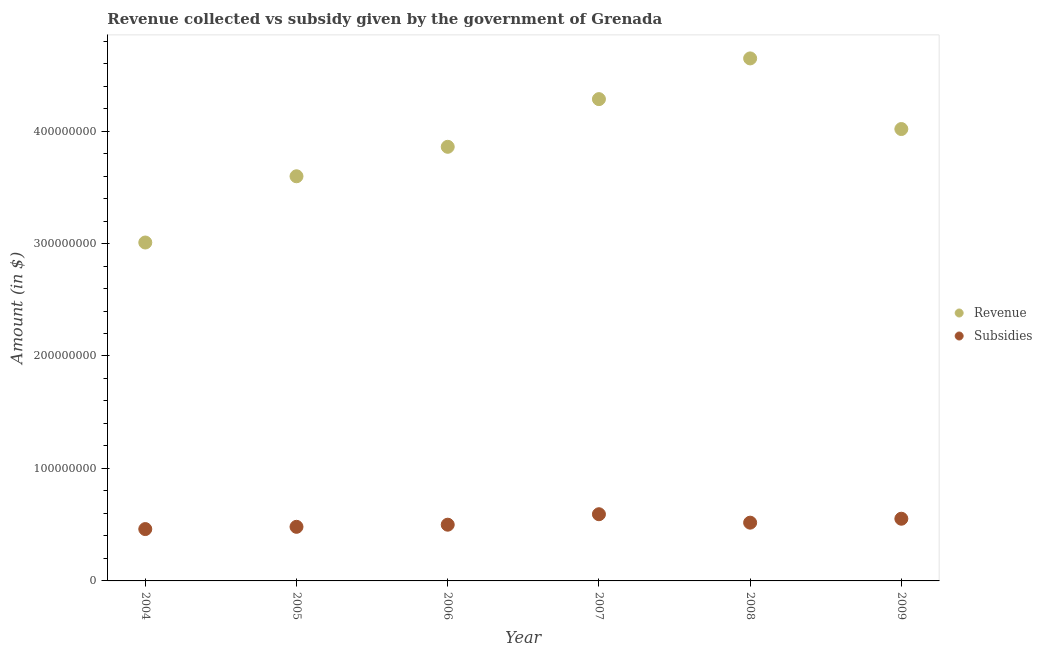How many different coloured dotlines are there?
Offer a very short reply. 2. Is the number of dotlines equal to the number of legend labels?
Your response must be concise. Yes. What is the amount of revenue collected in 2008?
Your answer should be compact. 4.65e+08. Across all years, what is the maximum amount of subsidies given?
Give a very brief answer. 5.93e+07. Across all years, what is the minimum amount of revenue collected?
Provide a short and direct response. 3.01e+08. In which year was the amount of revenue collected maximum?
Offer a very short reply. 2008. What is the total amount of subsidies given in the graph?
Give a very brief answer. 3.11e+08. What is the difference between the amount of revenue collected in 2006 and that in 2009?
Your response must be concise. -1.58e+07. What is the difference between the amount of subsidies given in 2007 and the amount of revenue collected in 2005?
Your response must be concise. -3.00e+08. What is the average amount of revenue collected per year?
Provide a succinct answer. 3.90e+08. In the year 2008, what is the difference between the amount of subsidies given and amount of revenue collected?
Provide a succinct answer. -4.13e+08. In how many years, is the amount of subsidies given greater than 320000000 $?
Your answer should be very brief. 0. What is the ratio of the amount of revenue collected in 2008 to that in 2009?
Offer a very short reply. 1.16. What is the difference between the highest and the second highest amount of subsidies given?
Keep it short and to the point. 4.00e+06. What is the difference between the highest and the lowest amount of subsidies given?
Your answer should be compact. 1.32e+07. In how many years, is the amount of subsidies given greater than the average amount of subsidies given taken over all years?
Provide a succinct answer. 3. Is the amount of revenue collected strictly greater than the amount of subsidies given over the years?
Your response must be concise. Yes. How many dotlines are there?
Ensure brevity in your answer.  2. How many years are there in the graph?
Provide a short and direct response. 6. What is the difference between two consecutive major ticks on the Y-axis?
Offer a very short reply. 1.00e+08. Does the graph contain grids?
Ensure brevity in your answer.  No. What is the title of the graph?
Your answer should be compact. Revenue collected vs subsidy given by the government of Grenada. Does "Forest" appear as one of the legend labels in the graph?
Ensure brevity in your answer.  No. What is the label or title of the X-axis?
Ensure brevity in your answer.  Year. What is the label or title of the Y-axis?
Offer a very short reply. Amount (in $). What is the Amount (in $) of Revenue in 2004?
Provide a short and direct response. 3.01e+08. What is the Amount (in $) in Subsidies in 2004?
Your answer should be compact. 4.61e+07. What is the Amount (in $) in Revenue in 2005?
Your answer should be compact. 3.60e+08. What is the Amount (in $) of Subsidies in 2005?
Your answer should be very brief. 4.81e+07. What is the Amount (in $) in Revenue in 2006?
Keep it short and to the point. 3.86e+08. What is the Amount (in $) of Subsidies in 2006?
Give a very brief answer. 5.00e+07. What is the Amount (in $) in Revenue in 2007?
Give a very brief answer. 4.28e+08. What is the Amount (in $) in Subsidies in 2007?
Ensure brevity in your answer.  5.93e+07. What is the Amount (in $) in Revenue in 2008?
Your answer should be very brief. 4.65e+08. What is the Amount (in $) of Subsidies in 2008?
Make the answer very short. 5.18e+07. What is the Amount (in $) in Revenue in 2009?
Provide a succinct answer. 4.02e+08. What is the Amount (in $) in Subsidies in 2009?
Your answer should be very brief. 5.53e+07. Across all years, what is the maximum Amount (in $) of Revenue?
Keep it short and to the point. 4.65e+08. Across all years, what is the maximum Amount (in $) of Subsidies?
Provide a succinct answer. 5.93e+07. Across all years, what is the minimum Amount (in $) in Revenue?
Keep it short and to the point. 3.01e+08. Across all years, what is the minimum Amount (in $) in Subsidies?
Make the answer very short. 4.61e+07. What is the total Amount (in $) in Revenue in the graph?
Your answer should be compact. 2.34e+09. What is the total Amount (in $) of Subsidies in the graph?
Give a very brief answer. 3.11e+08. What is the difference between the Amount (in $) of Revenue in 2004 and that in 2005?
Keep it short and to the point. -5.89e+07. What is the difference between the Amount (in $) in Subsidies in 2004 and that in 2005?
Your response must be concise. -2.00e+06. What is the difference between the Amount (in $) in Revenue in 2004 and that in 2006?
Provide a succinct answer. -8.51e+07. What is the difference between the Amount (in $) in Subsidies in 2004 and that in 2006?
Make the answer very short. -3.90e+06. What is the difference between the Amount (in $) in Revenue in 2004 and that in 2007?
Your answer should be compact. -1.28e+08. What is the difference between the Amount (in $) of Subsidies in 2004 and that in 2007?
Ensure brevity in your answer.  -1.32e+07. What is the difference between the Amount (in $) of Revenue in 2004 and that in 2008?
Offer a very short reply. -1.64e+08. What is the difference between the Amount (in $) in Subsidies in 2004 and that in 2008?
Provide a succinct answer. -5.70e+06. What is the difference between the Amount (in $) in Revenue in 2004 and that in 2009?
Make the answer very short. -1.01e+08. What is the difference between the Amount (in $) of Subsidies in 2004 and that in 2009?
Keep it short and to the point. -9.20e+06. What is the difference between the Amount (in $) of Revenue in 2005 and that in 2006?
Your answer should be very brief. -2.62e+07. What is the difference between the Amount (in $) of Subsidies in 2005 and that in 2006?
Provide a short and direct response. -1.90e+06. What is the difference between the Amount (in $) in Revenue in 2005 and that in 2007?
Make the answer very short. -6.86e+07. What is the difference between the Amount (in $) in Subsidies in 2005 and that in 2007?
Your answer should be compact. -1.12e+07. What is the difference between the Amount (in $) of Revenue in 2005 and that in 2008?
Make the answer very short. -1.05e+08. What is the difference between the Amount (in $) in Subsidies in 2005 and that in 2008?
Provide a short and direct response. -3.70e+06. What is the difference between the Amount (in $) of Revenue in 2005 and that in 2009?
Your answer should be very brief. -4.20e+07. What is the difference between the Amount (in $) in Subsidies in 2005 and that in 2009?
Your answer should be compact. -7.20e+06. What is the difference between the Amount (in $) in Revenue in 2006 and that in 2007?
Offer a terse response. -4.24e+07. What is the difference between the Amount (in $) in Subsidies in 2006 and that in 2007?
Keep it short and to the point. -9.30e+06. What is the difference between the Amount (in $) in Revenue in 2006 and that in 2008?
Offer a terse response. -7.86e+07. What is the difference between the Amount (in $) of Subsidies in 2006 and that in 2008?
Provide a short and direct response. -1.80e+06. What is the difference between the Amount (in $) of Revenue in 2006 and that in 2009?
Ensure brevity in your answer.  -1.58e+07. What is the difference between the Amount (in $) in Subsidies in 2006 and that in 2009?
Keep it short and to the point. -5.30e+06. What is the difference between the Amount (in $) in Revenue in 2007 and that in 2008?
Provide a short and direct response. -3.62e+07. What is the difference between the Amount (in $) of Subsidies in 2007 and that in 2008?
Keep it short and to the point. 7.50e+06. What is the difference between the Amount (in $) of Revenue in 2007 and that in 2009?
Your response must be concise. 2.66e+07. What is the difference between the Amount (in $) of Subsidies in 2007 and that in 2009?
Your answer should be very brief. 4.00e+06. What is the difference between the Amount (in $) of Revenue in 2008 and that in 2009?
Make the answer very short. 6.28e+07. What is the difference between the Amount (in $) in Subsidies in 2008 and that in 2009?
Your response must be concise. -3.50e+06. What is the difference between the Amount (in $) of Revenue in 2004 and the Amount (in $) of Subsidies in 2005?
Provide a short and direct response. 2.53e+08. What is the difference between the Amount (in $) in Revenue in 2004 and the Amount (in $) in Subsidies in 2006?
Ensure brevity in your answer.  2.51e+08. What is the difference between the Amount (in $) of Revenue in 2004 and the Amount (in $) of Subsidies in 2007?
Offer a terse response. 2.42e+08. What is the difference between the Amount (in $) in Revenue in 2004 and the Amount (in $) in Subsidies in 2008?
Offer a terse response. 2.49e+08. What is the difference between the Amount (in $) of Revenue in 2004 and the Amount (in $) of Subsidies in 2009?
Make the answer very short. 2.46e+08. What is the difference between the Amount (in $) in Revenue in 2005 and the Amount (in $) in Subsidies in 2006?
Offer a terse response. 3.10e+08. What is the difference between the Amount (in $) in Revenue in 2005 and the Amount (in $) in Subsidies in 2007?
Ensure brevity in your answer.  3.00e+08. What is the difference between the Amount (in $) of Revenue in 2005 and the Amount (in $) of Subsidies in 2008?
Your answer should be very brief. 3.08e+08. What is the difference between the Amount (in $) of Revenue in 2005 and the Amount (in $) of Subsidies in 2009?
Provide a succinct answer. 3.04e+08. What is the difference between the Amount (in $) of Revenue in 2006 and the Amount (in $) of Subsidies in 2007?
Offer a very short reply. 3.27e+08. What is the difference between the Amount (in $) in Revenue in 2006 and the Amount (in $) in Subsidies in 2008?
Offer a terse response. 3.34e+08. What is the difference between the Amount (in $) of Revenue in 2006 and the Amount (in $) of Subsidies in 2009?
Offer a terse response. 3.31e+08. What is the difference between the Amount (in $) of Revenue in 2007 and the Amount (in $) of Subsidies in 2008?
Ensure brevity in your answer.  3.77e+08. What is the difference between the Amount (in $) of Revenue in 2007 and the Amount (in $) of Subsidies in 2009?
Give a very brief answer. 3.73e+08. What is the difference between the Amount (in $) in Revenue in 2008 and the Amount (in $) in Subsidies in 2009?
Provide a short and direct response. 4.09e+08. What is the average Amount (in $) of Revenue per year?
Your answer should be compact. 3.90e+08. What is the average Amount (in $) in Subsidies per year?
Your answer should be compact. 5.18e+07. In the year 2004, what is the difference between the Amount (in $) of Revenue and Amount (in $) of Subsidies?
Give a very brief answer. 2.55e+08. In the year 2005, what is the difference between the Amount (in $) of Revenue and Amount (in $) of Subsidies?
Offer a terse response. 3.12e+08. In the year 2006, what is the difference between the Amount (in $) in Revenue and Amount (in $) in Subsidies?
Your response must be concise. 3.36e+08. In the year 2007, what is the difference between the Amount (in $) of Revenue and Amount (in $) of Subsidies?
Ensure brevity in your answer.  3.69e+08. In the year 2008, what is the difference between the Amount (in $) of Revenue and Amount (in $) of Subsidies?
Offer a terse response. 4.13e+08. In the year 2009, what is the difference between the Amount (in $) in Revenue and Amount (in $) in Subsidies?
Ensure brevity in your answer.  3.46e+08. What is the ratio of the Amount (in $) in Revenue in 2004 to that in 2005?
Make the answer very short. 0.84. What is the ratio of the Amount (in $) of Subsidies in 2004 to that in 2005?
Make the answer very short. 0.96. What is the ratio of the Amount (in $) of Revenue in 2004 to that in 2006?
Keep it short and to the point. 0.78. What is the ratio of the Amount (in $) of Subsidies in 2004 to that in 2006?
Provide a short and direct response. 0.92. What is the ratio of the Amount (in $) in Revenue in 2004 to that in 2007?
Your answer should be compact. 0.7. What is the ratio of the Amount (in $) of Subsidies in 2004 to that in 2007?
Give a very brief answer. 0.78. What is the ratio of the Amount (in $) in Revenue in 2004 to that in 2008?
Your answer should be compact. 0.65. What is the ratio of the Amount (in $) in Subsidies in 2004 to that in 2008?
Your answer should be very brief. 0.89. What is the ratio of the Amount (in $) of Revenue in 2004 to that in 2009?
Give a very brief answer. 0.75. What is the ratio of the Amount (in $) of Subsidies in 2004 to that in 2009?
Give a very brief answer. 0.83. What is the ratio of the Amount (in $) of Revenue in 2005 to that in 2006?
Provide a short and direct response. 0.93. What is the ratio of the Amount (in $) in Subsidies in 2005 to that in 2006?
Make the answer very short. 0.96. What is the ratio of the Amount (in $) of Revenue in 2005 to that in 2007?
Provide a succinct answer. 0.84. What is the ratio of the Amount (in $) of Subsidies in 2005 to that in 2007?
Your answer should be compact. 0.81. What is the ratio of the Amount (in $) in Revenue in 2005 to that in 2008?
Ensure brevity in your answer.  0.77. What is the ratio of the Amount (in $) of Revenue in 2005 to that in 2009?
Ensure brevity in your answer.  0.9. What is the ratio of the Amount (in $) in Subsidies in 2005 to that in 2009?
Your response must be concise. 0.87. What is the ratio of the Amount (in $) of Revenue in 2006 to that in 2007?
Offer a terse response. 0.9. What is the ratio of the Amount (in $) of Subsidies in 2006 to that in 2007?
Your answer should be compact. 0.84. What is the ratio of the Amount (in $) in Revenue in 2006 to that in 2008?
Provide a succinct answer. 0.83. What is the ratio of the Amount (in $) of Subsidies in 2006 to that in 2008?
Provide a succinct answer. 0.97. What is the ratio of the Amount (in $) in Revenue in 2006 to that in 2009?
Provide a succinct answer. 0.96. What is the ratio of the Amount (in $) in Subsidies in 2006 to that in 2009?
Offer a very short reply. 0.9. What is the ratio of the Amount (in $) of Revenue in 2007 to that in 2008?
Offer a terse response. 0.92. What is the ratio of the Amount (in $) in Subsidies in 2007 to that in 2008?
Give a very brief answer. 1.14. What is the ratio of the Amount (in $) of Revenue in 2007 to that in 2009?
Provide a succinct answer. 1.07. What is the ratio of the Amount (in $) of Subsidies in 2007 to that in 2009?
Give a very brief answer. 1.07. What is the ratio of the Amount (in $) in Revenue in 2008 to that in 2009?
Offer a terse response. 1.16. What is the ratio of the Amount (in $) in Subsidies in 2008 to that in 2009?
Offer a very short reply. 0.94. What is the difference between the highest and the second highest Amount (in $) in Revenue?
Your answer should be compact. 3.62e+07. What is the difference between the highest and the second highest Amount (in $) in Subsidies?
Make the answer very short. 4.00e+06. What is the difference between the highest and the lowest Amount (in $) of Revenue?
Offer a terse response. 1.64e+08. What is the difference between the highest and the lowest Amount (in $) in Subsidies?
Provide a succinct answer. 1.32e+07. 